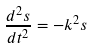<formula> <loc_0><loc_0><loc_500><loc_500>\frac { d ^ { 2 } s } { d t ^ { 2 } } = - k ^ { 2 } s</formula> 